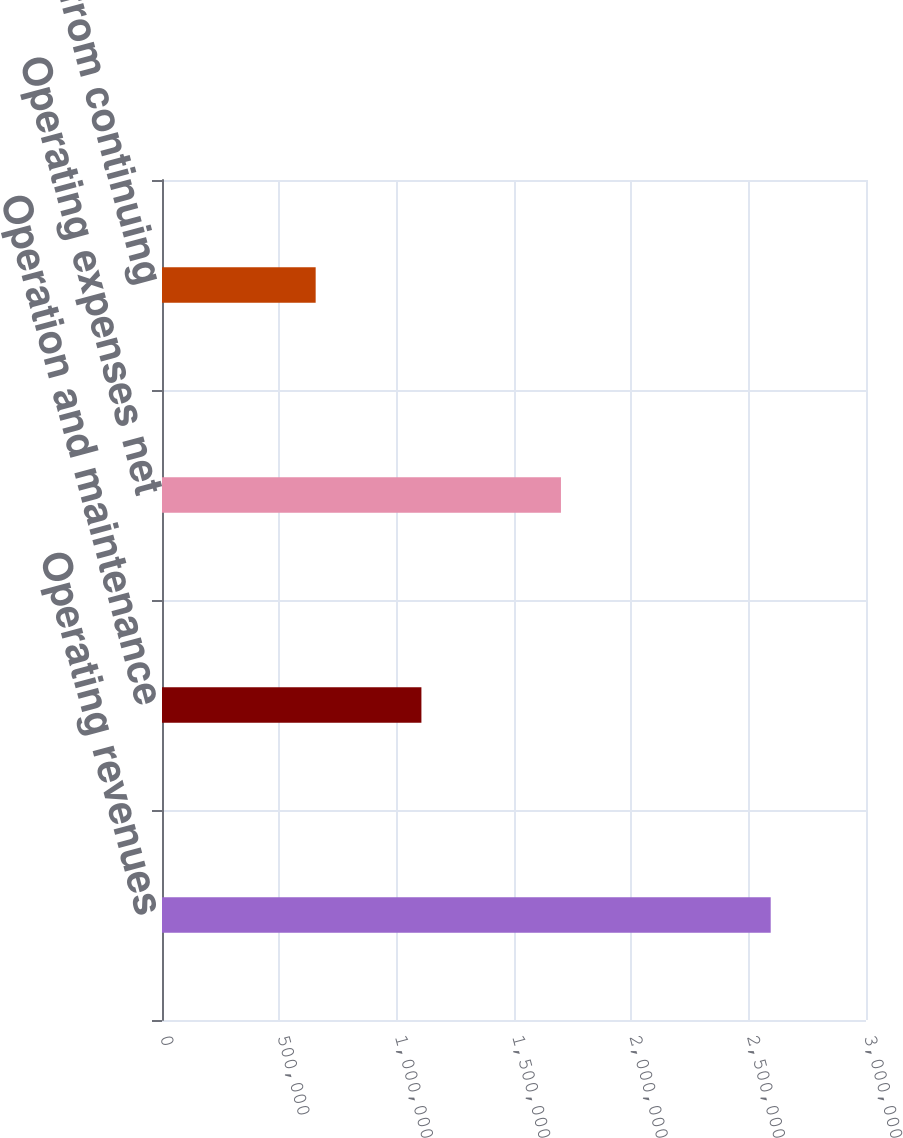Convert chart to OTSL. <chart><loc_0><loc_0><loc_500><loc_500><bar_chart><fcel>Operating revenues<fcel>Operation and maintenance<fcel>Operating expenses net<fcel>Income from continuing<nl><fcel>2.59392e+06<fcel>1.10544e+06<fcel>1.70005e+06<fcel>654834<nl></chart> 